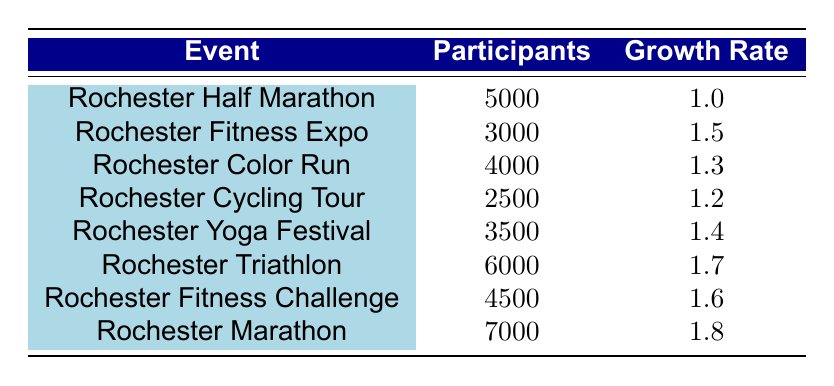What was the highest number of participants in a fitness event from 2016 to 2023? The table shows the number of participants for each event over the years. The highest number can be found by scanning the "Participants" column, which reveals that the Rochester Marathon had 7000 participants in 2023.
Answer: 7000 Which event had the lowest participation rate? To identify the event with the lowest participation, we look for the minimum value in the "Participants" column. The Rochester Cycling Tour had the lowest with 2500 participants in 2019.
Answer: 2500 What is the average growth rate of all events from 2016 to 2023? To calculate the average growth rate, we sum the growth rates from each event (1.0 + 1.5 + 1.3 + 1.2 + 1.4 + 1.7 + 1.6 + 1.8) which equals 10.5. There are 8 events, so the average growth rate is 10.5 divided by 8, which results in 1.3125.
Answer: 1.3125 Did the participation rate for the Rochester Triathlon increase compared to the previous year? We compare the number of participants in the Rochester Triathlon (6000 in 2021) with the previous year, the Rochester Yoga Festival (3500 in 2020). Since 6000 is higher than 3500, the participation rate increased.
Answer: Yes What is the total number of participants from all events in 2022 and 2023? We need to find the total of the participants in those years. The Rochester Fitness Challenge had 4500 participants in 2022, and the Rochester Marathon had 7000 participants in 2023. Adding these numbers together (4500 + 7000) gives us a total of 11500 participants.
Answer: 11500 Which fitness event experienced the highest growth rate? To determine which event had the highest growth rate, we compare the "Growth Rate" values for all events. The Rochester Marathon had the highest growth rate of 1.8 in 2023.
Answer: 1.8 In which year did the Rochester Color Run occur? The table specifies that the Rochester Color Run took place in 2018. By checking the "Event" column for that specific title, we can confirm the year.
Answer: 2018 Was there a growth in participation from the Rochester Half Marathon in 2016 to the Rochester Fitness Expo in 2017? We compare the number of participants between the two events: 5000 for the Half Marathon in 2016 and 3000 for the Fitness Expo in 2017. Since 3000 is less than 5000, there was a decline in participation.
Answer: No 